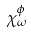Convert formula to latex. <formula><loc_0><loc_0><loc_500><loc_500>\chi _ { \omega } ^ { \phi }</formula> 